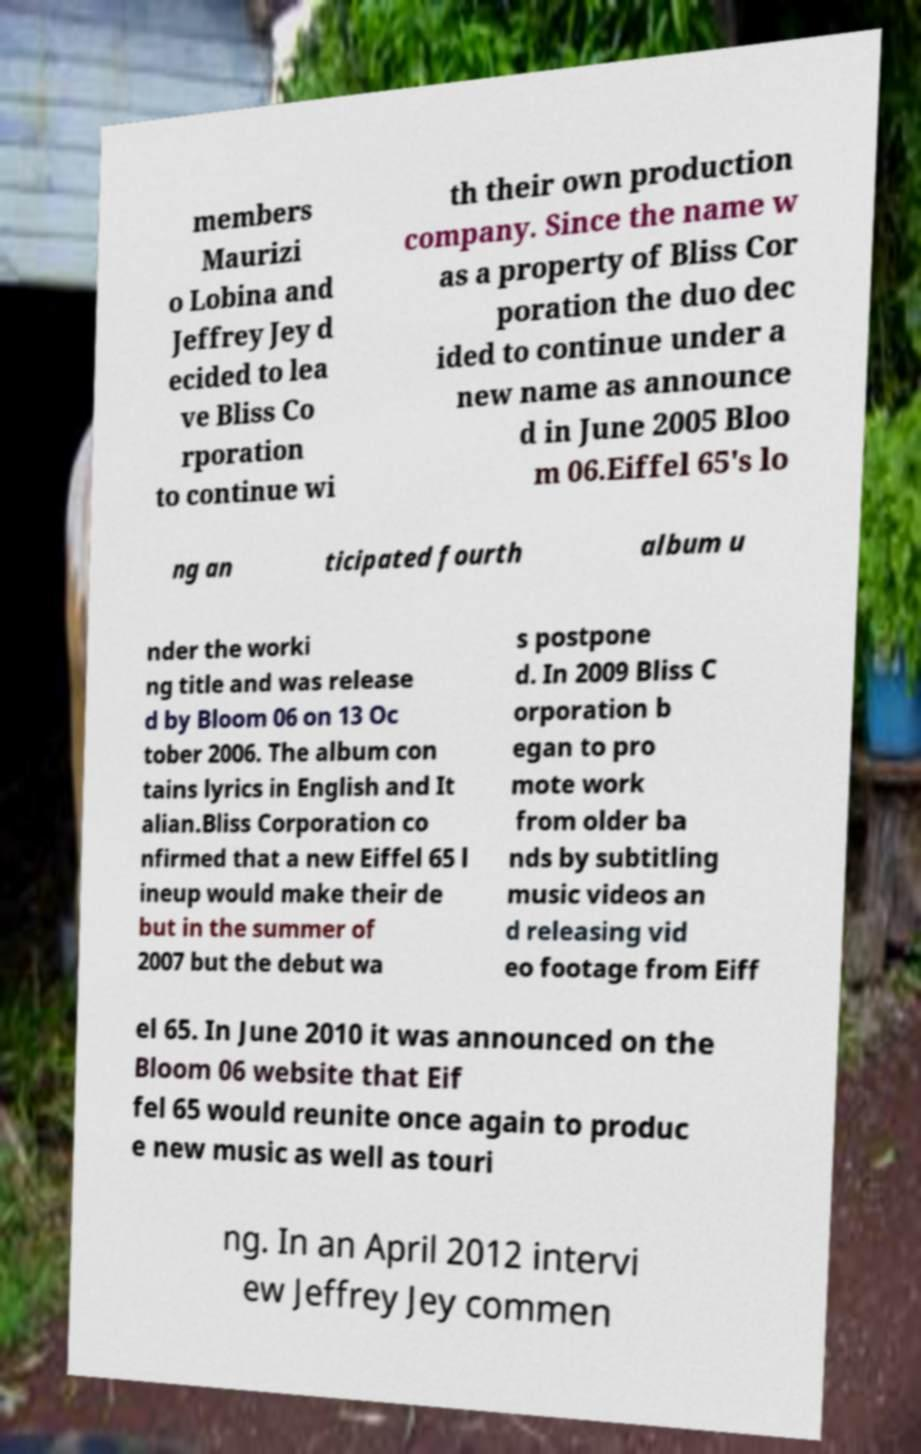Could you assist in decoding the text presented in this image and type it out clearly? members Maurizi o Lobina and Jeffrey Jey d ecided to lea ve Bliss Co rporation to continue wi th their own production company. Since the name w as a property of Bliss Cor poration the duo dec ided to continue under a new name as announce d in June 2005 Bloo m 06.Eiffel 65's lo ng an ticipated fourth album u nder the worki ng title and was release d by Bloom 06 on 13 Oc tober 2006. The album con tains lyrics in English and It alian.Bliss Corporation co nfirmed that a new Eiffel 65 l ineup would make their de but in the summer of 2007 but the debut wa s postpone d. In 2009 Bliss C orporation b egan to pro mote work from older ba nds by subtitling music videos an d releasing vid eo footage from Eiff el 65. In June 2010 it was announced on the Bloom 06 website that Eif fel 65 would reunite once again to produc e new music as well as touri ng. In an April 2012 intervi ew Jeffrey Jey commen 